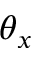<formula> <loc_0><loc_0><loc_500><loc_500>\theta _ { x }</formula> 